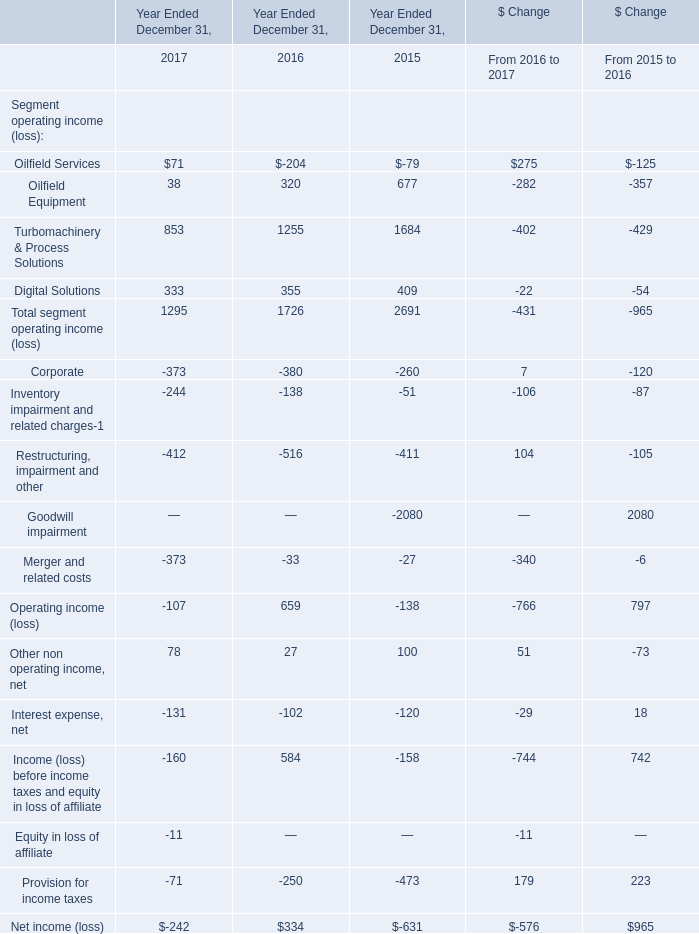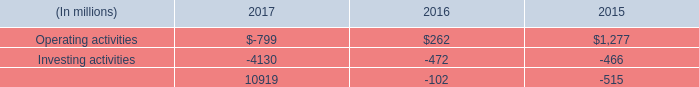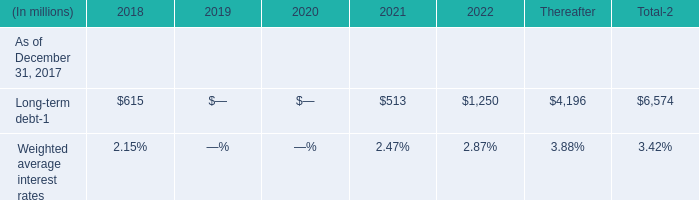What's the sum of the Oilfield Services in the years where Oilfield Services is positive? 
Answer: 71. 